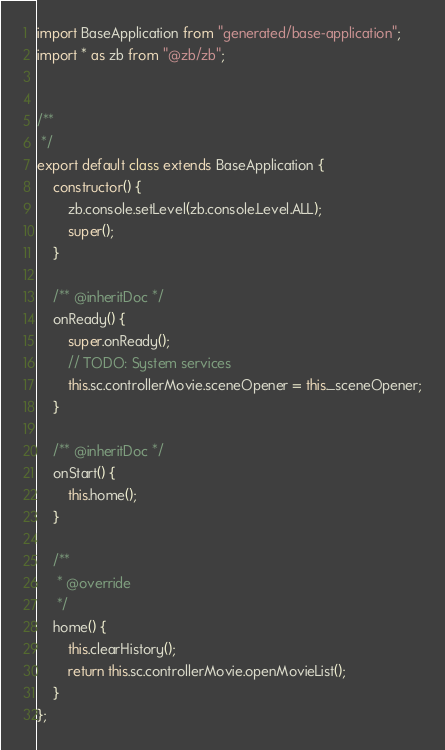<code> <loc_0><loc_0><loc_500><loc_500><_JavaScript_>import BaseApplication from "generated/base-application";
import * as zb from "@zb/zb";


/**
 */
export default class extends BaseApplication {
	constructor() {
		zb.console.setLevel(zb.console.Level.ALL);
		super();
	}

	/** @inheritDoc */
	onReady() {
		super.onReady();
		// TODO: System services
		this.sc.controllerMovie.sceneOpener = this._sceneOpener;
	}

	/** @inheritDoc */
	onStart() {
		this.home();
	}

	/**
	 * @override
	 */
	home() {
		this.clearHistory();
		return this.sc.controllerMovie.openMovieList();
	}
};
</code> 